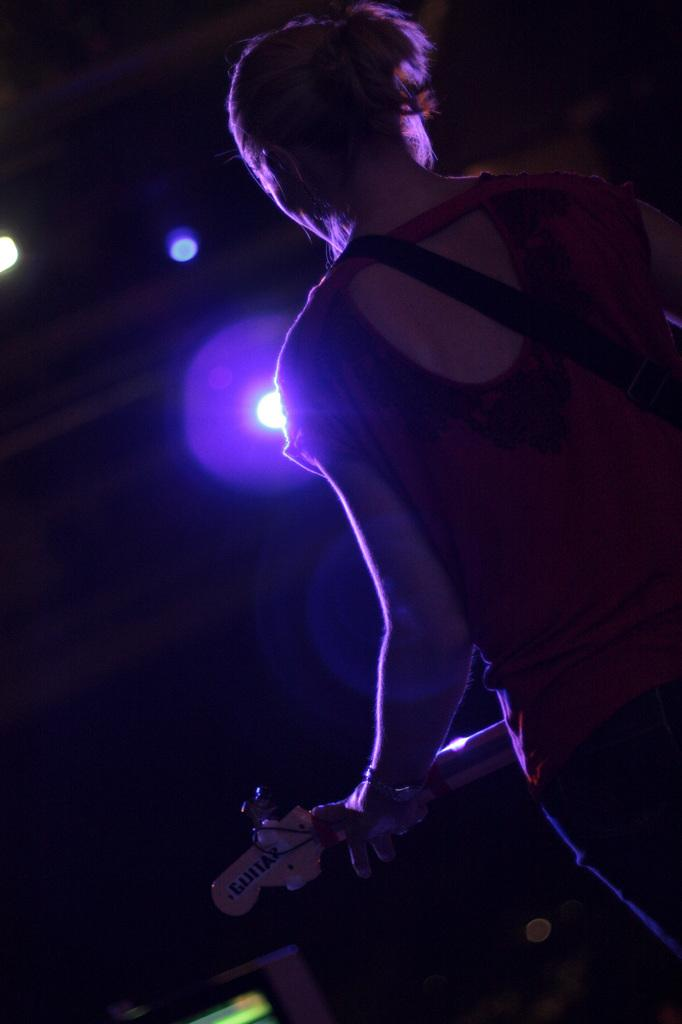What is the person in the image doing? The person is standing and holding a guitar. What object is the person holding in the image? The person is holding a guitar. What can be seen in the background of the image? There are lights visible in the background of the image. How would you describe the lighting conditions in the image? The image appears to be set in a dark environment. What type of kite is the person flying in the image? There is no kite present in the image; the person is holding a guitar. 